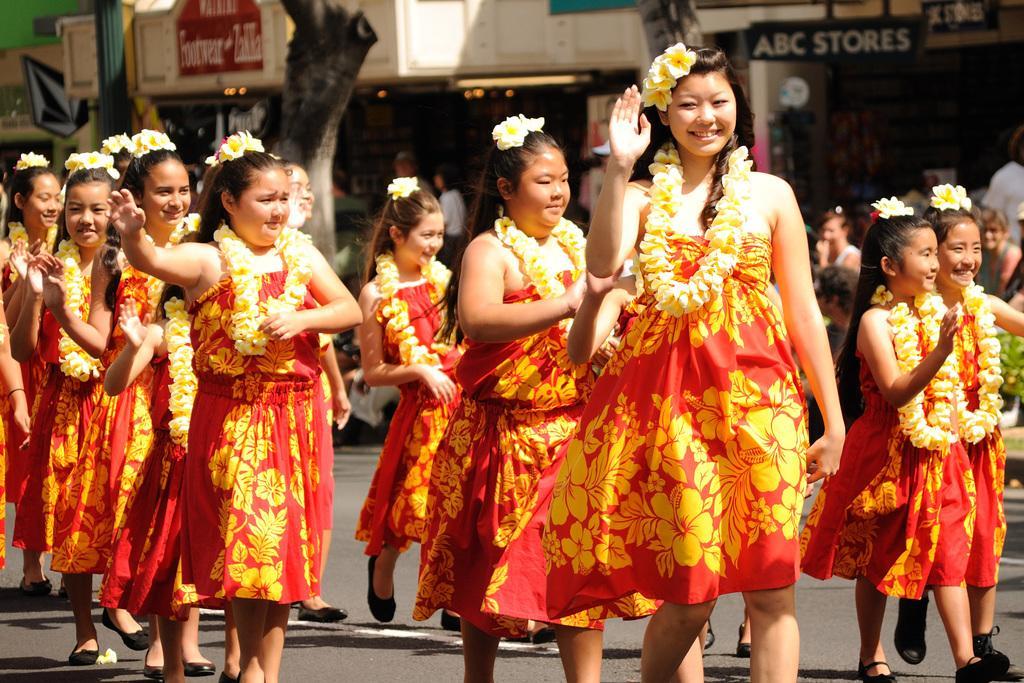Could you give a brief overview of what you see in this image? In this picture there are some girls walking on the road. They are wearing red and yellow color dresses. I can observe garlands in their necks. Some of them are smiling. In the background there are buildings. 